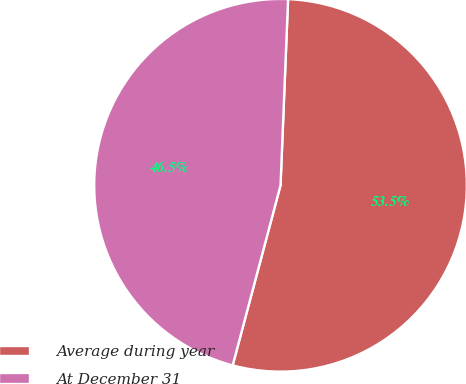Convert chart to OTSL. <chart><loc_0><loc_0><loc_500><loc_500><pie_chart><fcel>Average during year<fcel>At December 31<nl><fcel>53.49%<fcel>46.51%<nl></chart> 